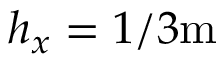<formula> <loc_0><loc_0><loc_500><loc_500>h _ { x } = 1 / 3 m</formula> 